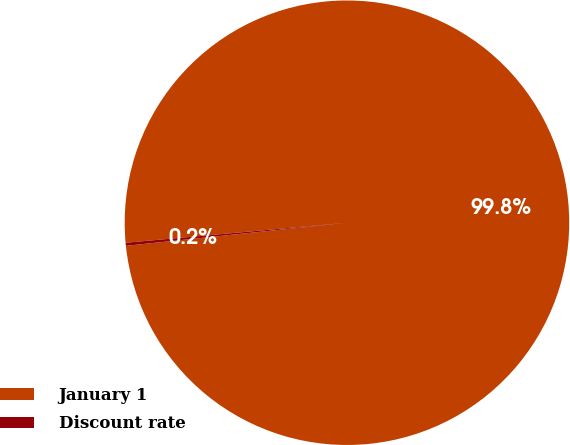Convert chart to OTSL. <chart><loc_0><loc_0><loc_500><loc_500><pie_chart><fcel>January 1<fcel>Discount rate<nl><fcel>99.78%<fcel>0.22%<nl></chart> 